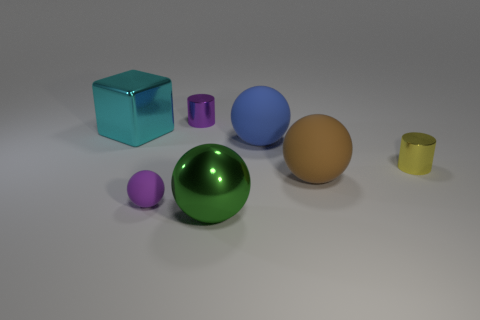Is the number of matte things left of the blue rubber object greater than the number of purple metal cylinders that are behind the purple metal cylinder?
Offer a very short reply. Yes. What shape is the thing that is in front of the yellow metallic object and on the left side of the green metal sphere?
Offer a very short reply. Sphere. The large metallic thing that is in front of the big brown sphere has what shape?
Offer a terse response. Sphere. There is a cylinder to the right of the cylinder on the left side of the cylinder on the right side of the purple metallic object; what is its size?
Give a very brief answer. Small. Do the blue object and the green thing have the same shape?
Keep it short and to the point. Yes. There is a metal object that is left of the metallic sphere and right of the purple matte thing; what is its size?
Provide a short and direct response. Small. What is the material of the other tiny thing that is the same shape as the yellow object?
Your answer should be very brief. Metal. What material is the object to the left of the small thing that is in front of the large brown object made of?
Offer a very short reply. Metal. Is the shape of the big cyan metal object the same as the object right of the big brown thing?
Provide a short and direct response. No. How many matte objects are either cyan blocks or purple balls?
Offer a terse response. 1. 